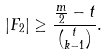<formula> <loc_0><loc_0><loc_500><loc_500>| F _ { 2 } | \geq \frac { \frac { m } { 2 } - t } { \binom { t } { k - 1 } } .</formula> 